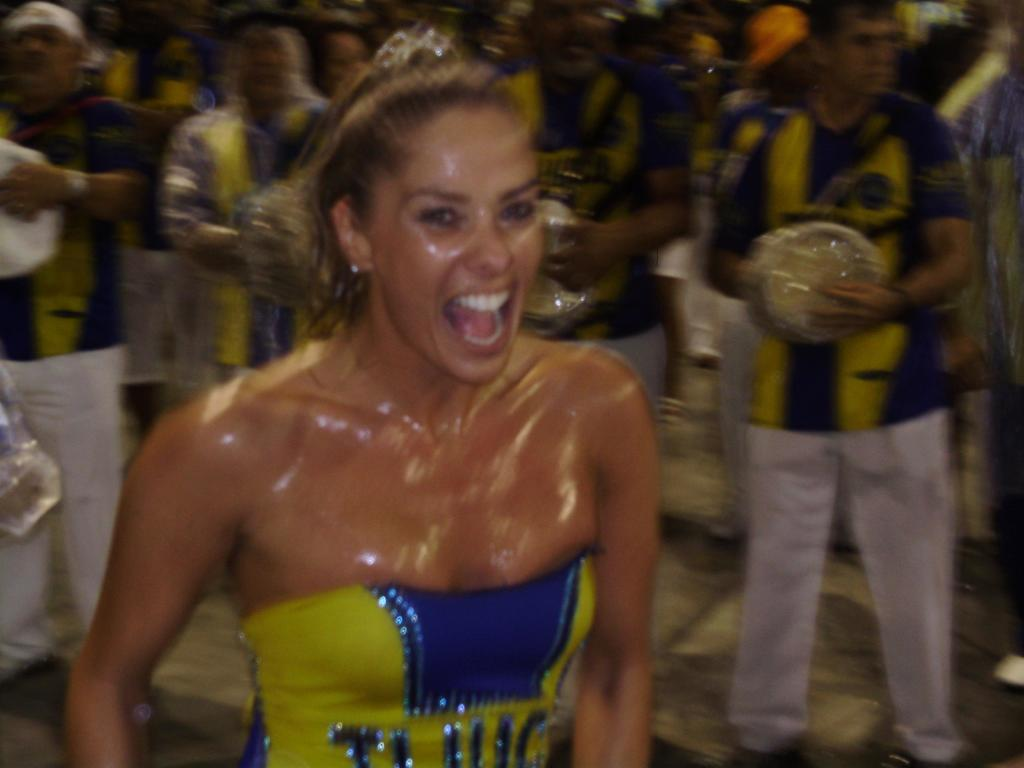Who is the main subject in the foreground of the picture? There is a woman in the foreground of the picture. What can be observed about the background of the image? The background of the image is blurred. Can you describe the people in the background of the image? There are people standing in the background of the image. What type of fairies can be seen flying around the woman in the image? There are no fairies present in the image. What kind of structure is visible behind the woman in the image? There is no structure visible behind the woman in the image. 